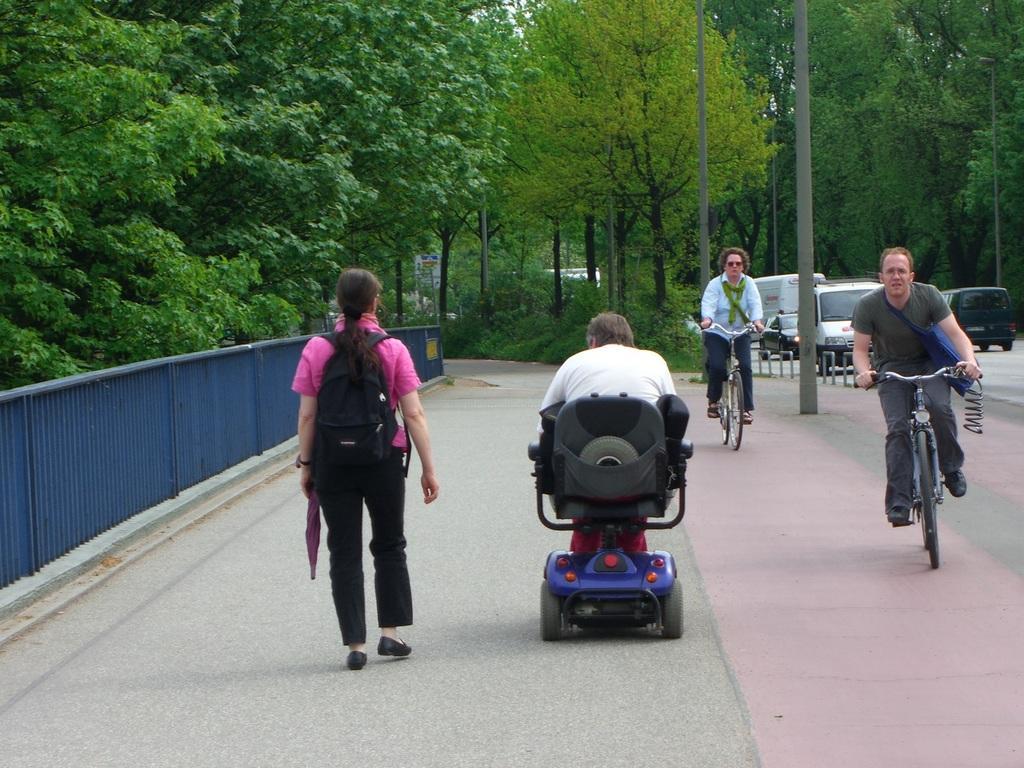In one or two sentences, can you explain what this image depicts? These two persons are riding bicycles and wire bag. This man is sitting on a chair. This woman is walking as there is a leg movement and wire bag. Far there are number of trees. Vehicles on road. This is fence in blue color. 